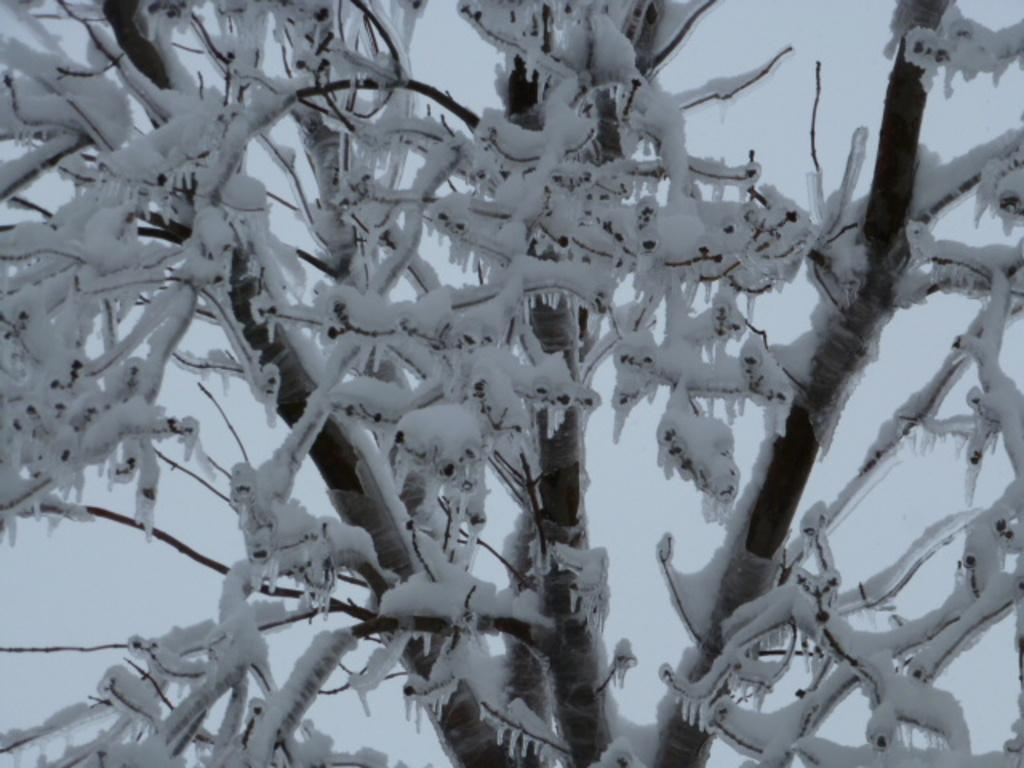What is covering the branches in the image? The branches are covered with snow in the image. What color dominates the background of the image? The background of the image is white. What type of shirt is being worn by the person in the image? There is no person present in the image, so it is not possible to determine what type of shirt they might be wearing. 